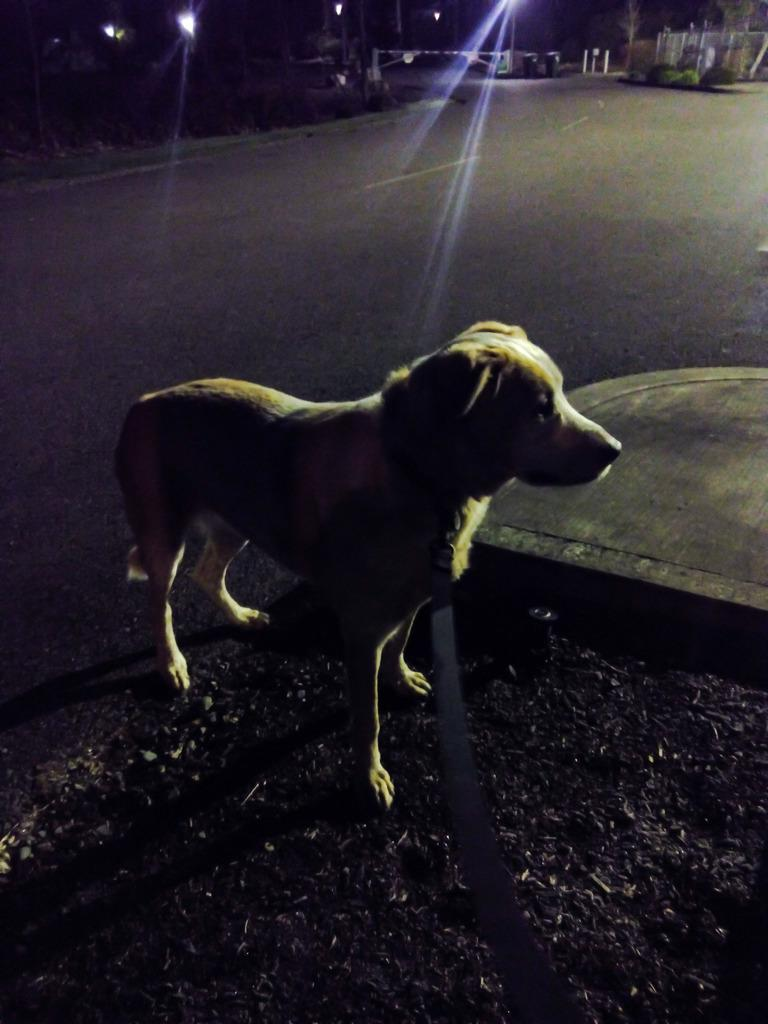What animal is present in the image? There is a dog in the image. Where is the dog located? The dog is on the floor. What else can be seen in the image besides the dog? There are other things visible in the image. Can you describe the lighting in the image? There are lights in the image. How many sacks are being destroyed by the dog in the image? There are no sacks or destruction present in the image; it features a dog on the floor. What type of dolls are interacting with the dog in the image? There are no dolls present in the image; it features a dog on the floor. 